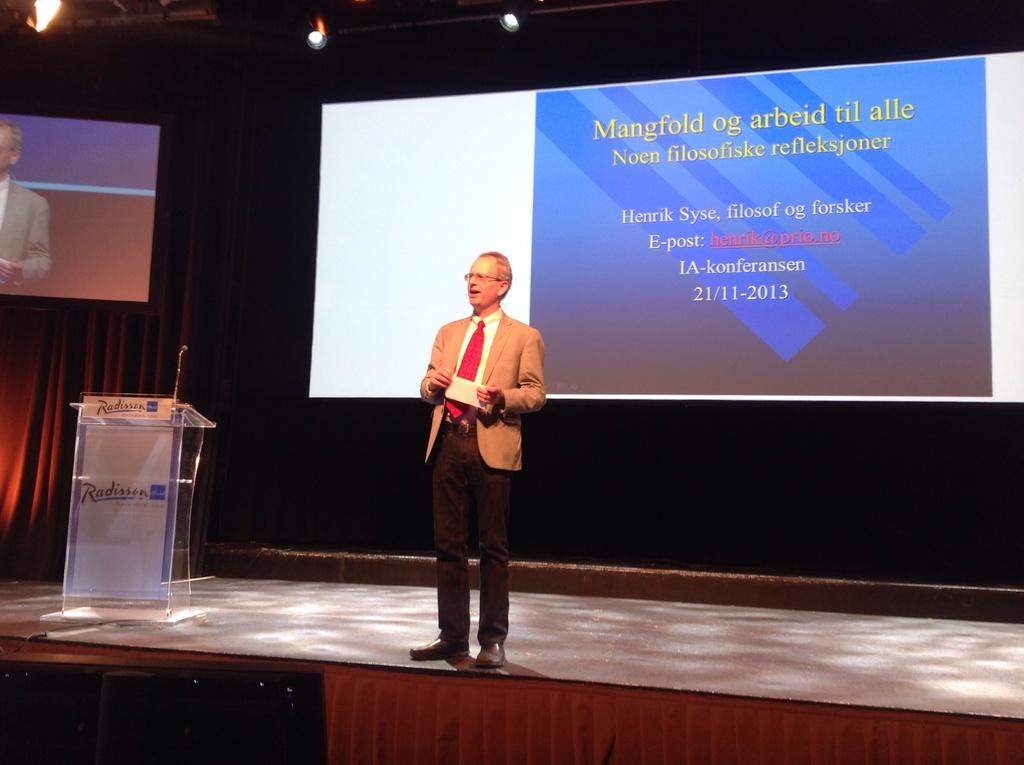<image>
Offer a succinct explanation of the picture presented. A man publicly speaking with a podium nearby that says Radisson on it. 